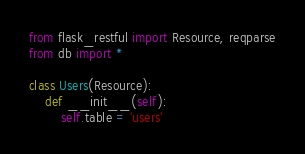<code> <loc_0><loc_0><loc_500><loc_500><_Python_>from flask_restful import Resource, reqparse
from db import *

class Users(Resource):
    def __init__(self):
        self.table = 'users'</code> 